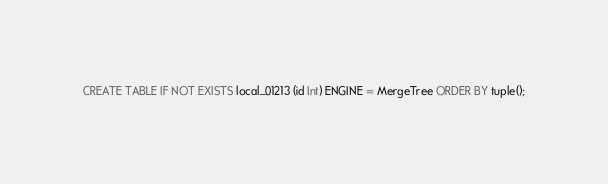Convert code to text. <code><loc_0><loc_0><loc_500><loc_500><_SQL_>CREATE TABLE IF NOT EXISTS local_01213 (id Int) ENGINE = MergeTree ORDER BY tuple();</code> 